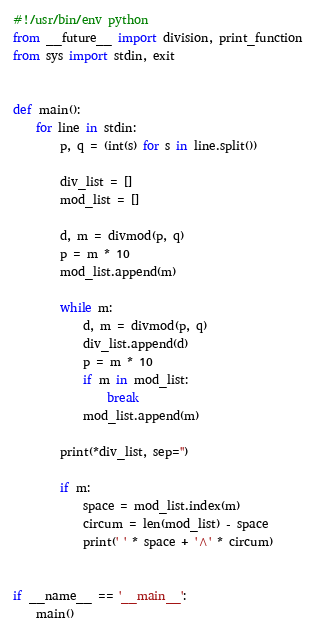<code> <loc_0><loc_0><loc_500><loc_500><_Python_>#!/usr/bin/env python
from __future__ import division, print_function
from sys import stdin, exit


def main():
    for line in stdin:
        p, q = (int(s) for s in line.split())

        div_list = []
        mod_list = []

        d, m = divmod(p, q)
        p = m * 10
        mod_list.append(m)

        while m:
            d, m = divmod(p, q)
            div_list.append(d)
            p = m * 10
            if m in mod_list:
                break
            mod_list.append(m)

        print(*div_list, sep='')

        if m:
            space = mod_list.index(m)
            circum = len(mod_list) - space
            print(' ' * space + '^' * circum)


if __name__ == '__main__':
    main()</code> 